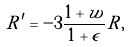Convert formula to latex. <formula><loc_0><loc_0><loc_500><loc_500>R ^ { \prime } = - 3 \frac { 1 + w } { 1 + \epsilon } R ,</formula> 